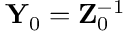Convert formula to latex. <formula><loc_0><loc_0><loc_500><loc_500>{ Y } _ { 0 } = { Z } _ { 0 } ^ { - 1 }</formula> 